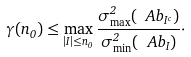<formula> <loc_0><loc_0><loc_500><loc_500>\gamma ( n _ { 0 } ) \leq \max _ { | I | \leq n _ { 0 } } \frac { \sigma ^ { 2 } _ { \max } ( \ A b _ { I ^ { c } } ) } { \sigma ^ { 2 } _ { \min } ( \ A b _ { I } ) } \cdot</formula> 